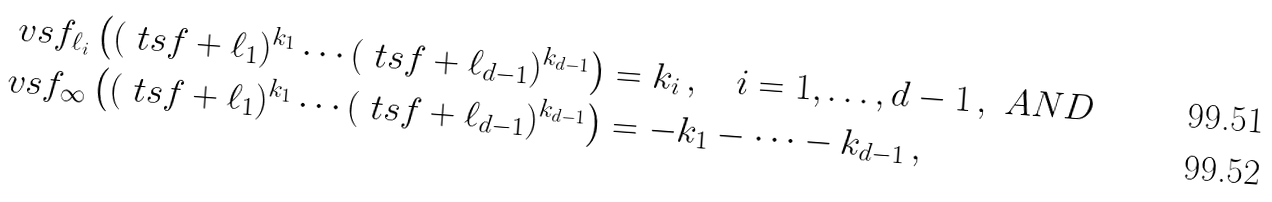Convert formula to latex. <formula><loc_0><loc_0><loc_500><loc_500>\ v s f _ { \ell _ { i } } \left ( ( \ t s f + \ell _ { 1 } ) ^ { k _ { 1 } } \cdots ( \ t s f + \ell _ { d - 1 } ) ^ { k _ { d - 1 } } \right ) & = k _ { i } \, , \quad i = 1 , \dots , d - 1 \, , \ A N D \\ \ v s f _ { \infty } \left ( ( \ t s f + \ell _ { 1 } ) ^ { k _ { 1 } } \cdots ( \ t s f + \ell _ { d - 1 } ) ^ { k _ { d - 1 } } \right ) & = - k _ { 1 } - \dots - k _ { d - 1 } \, ,</formula> 